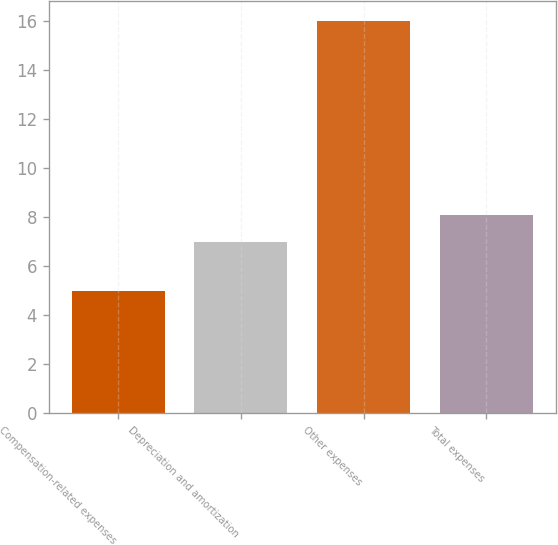Convert chart to OTSL. <chart><loc_0><loc_0><loc_500><loc_500><bar_chart><fcel>Compensation-related expenses<fcel>Depreciation and amortization<fcel>Other expenses<fcel>Total expenses<nl><fcel>5<fcel>7<fcel>16<fcel>8.1<nl></chart> 